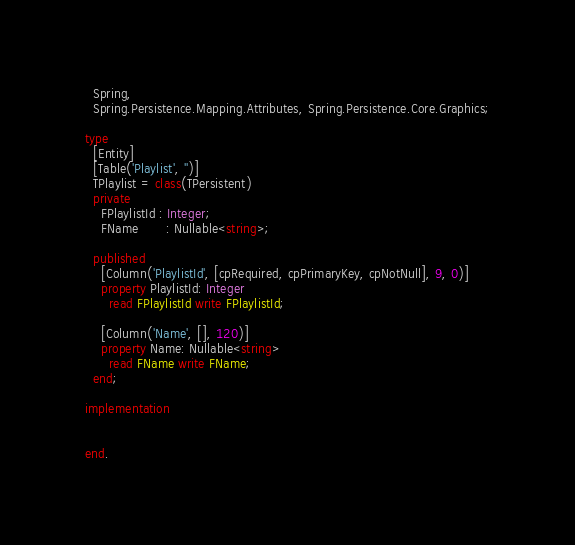<code> <loc_0><loc_0><loc_500><loc_500><_Pascal_>
  Spring,
  Spring.Persistence.Mapping.Attributes, Spring.Persistence.Core.Graphics;

type
  [Entity]
  [Table('Playlist', '')]
  TPlaylist = class(TPersistent)
  private
    FPlaylistId : Integer;
    FName       : Nullable<string>;

  published
    [Column('PlaylistId', [cpRequired, cpPrimaryKey, cpNotNull], 9, 0)]
    property PlaylistId: Integer
      read FPlaylistId write FPlaylistId;

    [Column('Name', [], 120)]
    property Name: Nullable<string>
      read FName write FName;
  end;

implementation


end.
</code> 